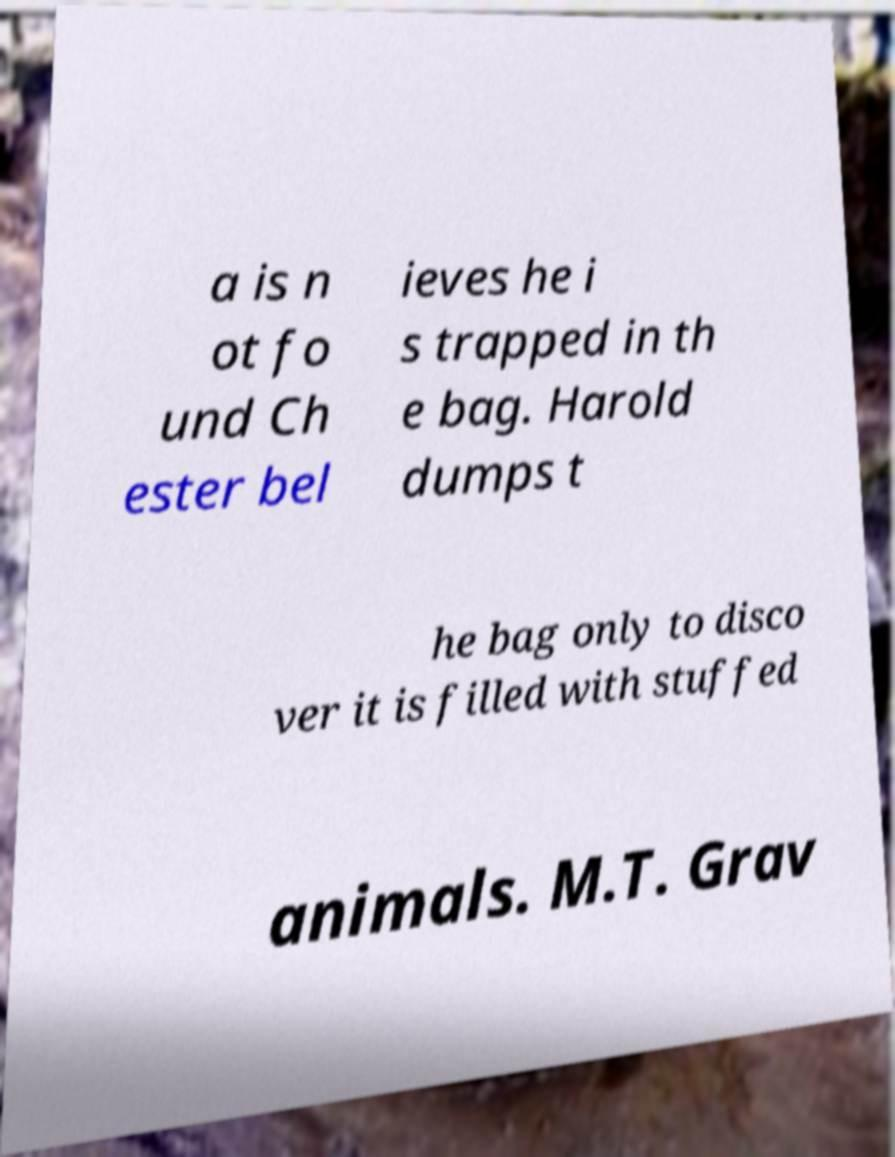I need the written content from this picture converted into text. Can you do that? a is n ot fo und Ch ester bel ieves he i s trapped in th e bag. Harold dumps t he bag only to disco ver it is filled with stuffed animals. M.T. Grav 